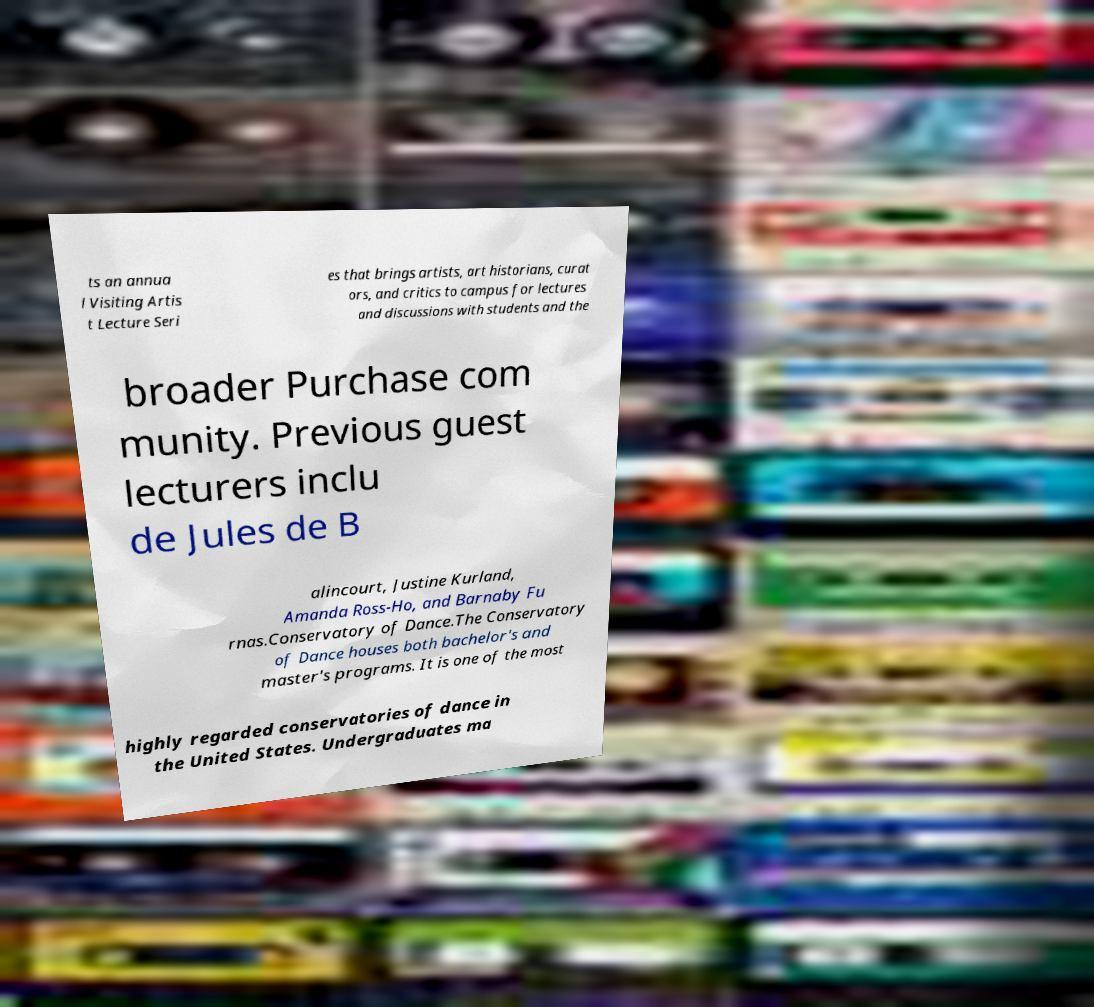For documentation purposes, I need the text within this image transcribed. Could you provide that? ts an annua l Visiting Artis t Lecture Seri es that brings artists, art historians, curat ors, and critics to campus for lectures and discussions with students and the broader Purchase com munity. Previous guest lecturers inclu de Jules de B alincourt, Justine Kurland, Amanda Ross-Ho, and Barnaby Fu rnas.Conservatory of Dance.The Conservatory of Dance houses both bachelor's and master's programs. It is one of the most highly regarded conservatories of dance in the United States. Undergraduates ma 